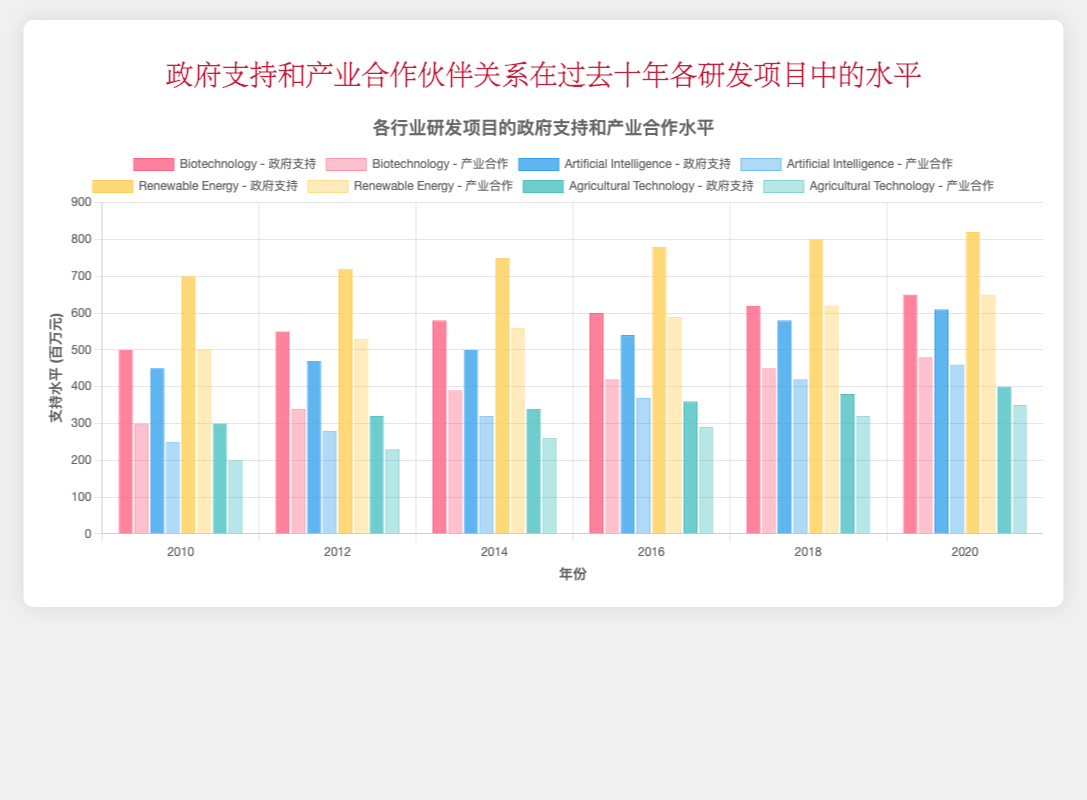Which sector had the highest level of government support in 2020? Look at the bar corresponding to the year 2020 for each sector and compare the heights. The Renewable Energy sector had the highest level, with government support at 820 million.
Answer: Renewable Energy How did industry partnerships in the Biotechnology sector evolve from 2010 to 2020? Check the bars representing industry partnerships in Biotechnology across the years. The values are 300 (2010), 340 (2012), 390 (2014), 420 (2016), 450 (2018), and 480 (2020), showing a consistent increase.
Answer: Increased Which sector had the least government support in 2018? Compare the heights of the government support bars for 2018 across all sectors. Agricultural Technology had the lowest with 380 million.
Answer: Agricultural Technology What was the total industry partnership funding for Agricultural Technology from 2010 to 2020? Sum the values of industry partnerships for Agricultural Technology for each year. The values are 200 (2010), 230 (2012), 260 (2014), 290 (2016), 320 (2018), and 350 (2020). The total is 200 + 230 + 260 + 290 + 320 + 350 = 1650 million.
Answer: 1650 million Which sector showed the largest increase in government support from 2010 to 2020? Calculate the difference between the values in 2010 and 2020 for each sector. Biotechnology (650-500 = 150), Artificial Intelligence (610-450 = 160), Renewable Energy (820-700 = 120), Agricultural Technology (400-300 = 100); Artificial Intelligence showed the largest increase with a 160 million increase.
Answer: Artificial Intelligence Compare the government support and industry partnership levels in Renewable Energy in 2014. Which was higher? Check the values for both government support and industry partnerships in Renewable Energy for the year 2014. Government support was 750, while industry partnerships were 560. Government support was higher.
Answer: Government support What was the average level of industry partnerships in Artificial Intelligence between 2010 and 2020? Calculate the average of industry partnerships in Artificial Intelligence across the years: (250 + 280 + 320 + 370 + 420 + 460) / 6. The sum is 2100, so the average is 2100 / 6 = 350 million.
Answer: 350 million Did any sector appear to have perfectly equal government support and industry partnerships at any year? Check all pairs across the years for equality. No pairs have equal values.
Answer: No 